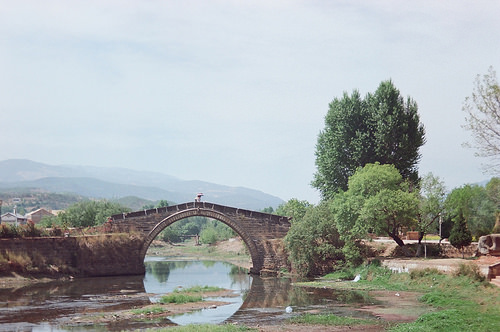<image>
Can you confirm if the bridge is to the right of the building? Yes. From this viewpoint, the bridge is positioned to the right side relative to the building. 